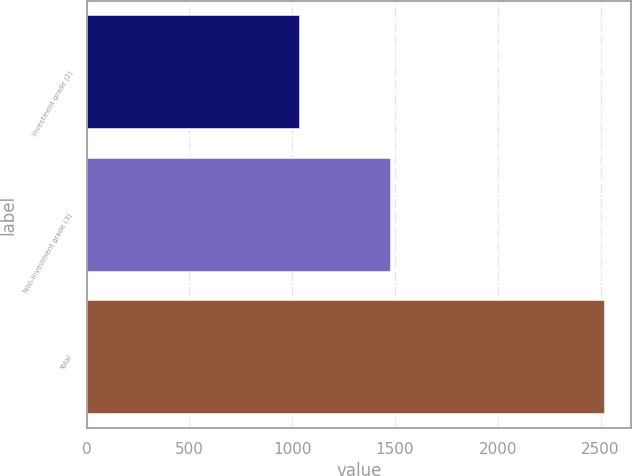<chart> <loc_0><loc_0><loc_500><loc_500><bar_chart><fcel>Investment grade (2)<fcel>Non-investment grade (3)<fcel>Total<nl><fcel>1039<fcel>1483<fcel>2522<nl></chart> 